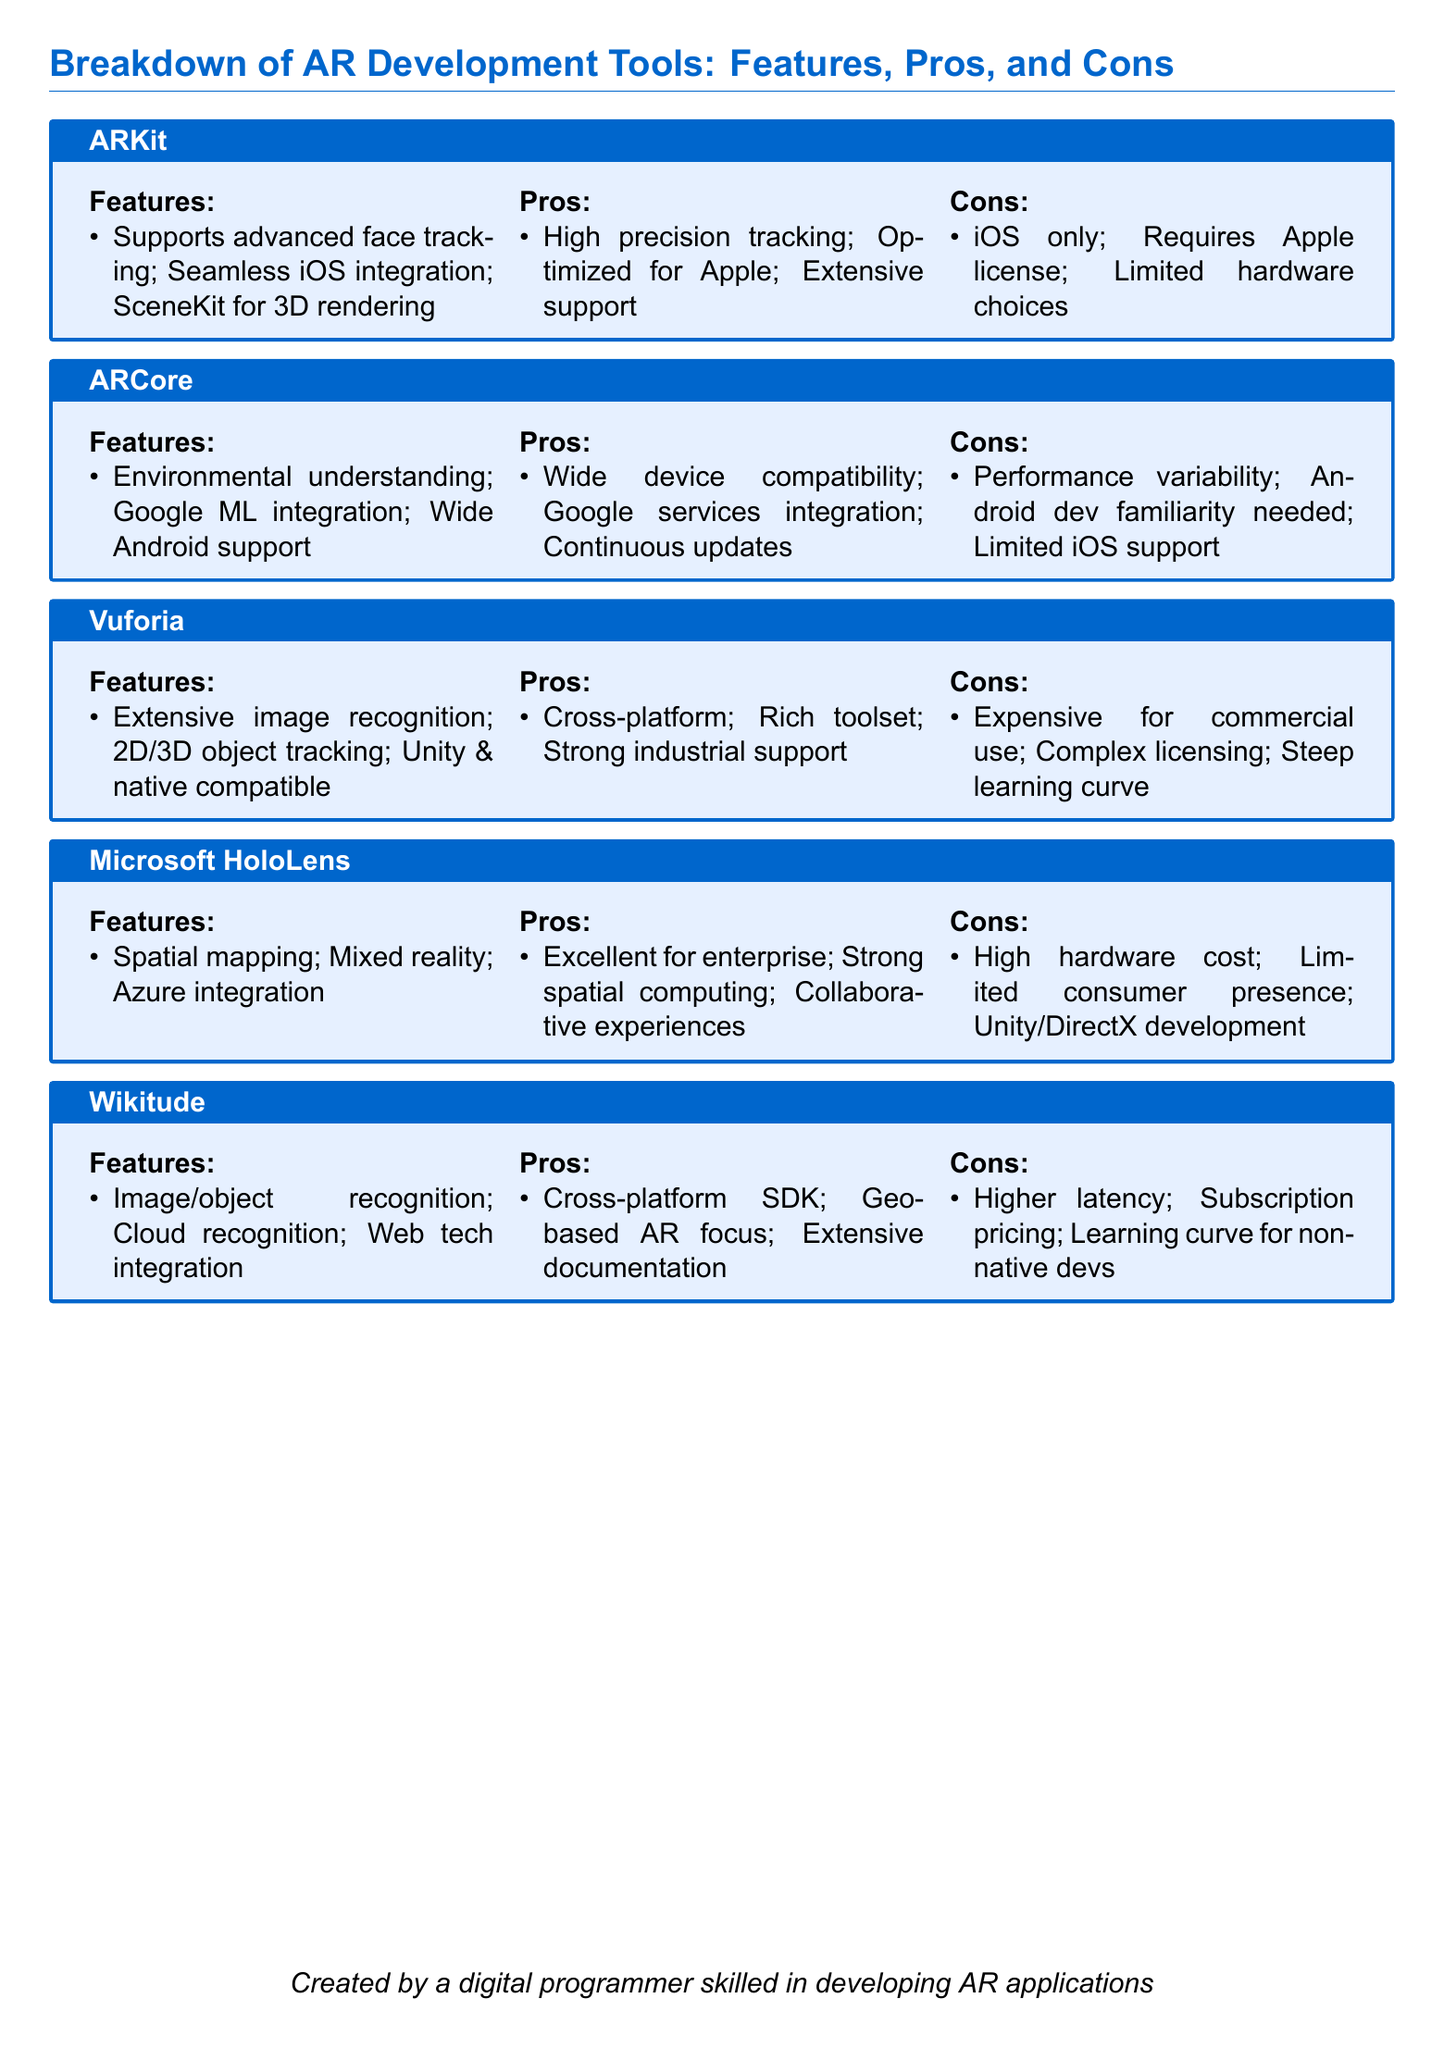What tool is iOS only? The tool that is iOS only is specified under the "Cons" section for ARKit.
Answer: ARKit What feature is unique to Vuforia? The unique feature of Vuforia mentioned is extensive image recognition.
Answer: Extensive image recognition Which tool integrates with Azure? The tool that integrates with Azure is Microsoft HoloLens.
Answer: Microsoft HoloLens What is a pro of using ARCore? A pro of using ARCore is its wide device compatibility.
Answer: Wide device compatibility What is the high hardware cost associated with? The high hardware cost is associated with Microsoft HoloLens.
Answer: Microsoft HoloLens What type of support does Vuforia provide? Vuforia provides strong industrial support.
Answer: Strong industrial support Which tool has limited iOS support? The tool that has limited iOS support is ARCore.
Answer: ARCore What is the common licensing issue with Vuforia? The common licensing issue with Vuforia is complex licensing.
Answer: Complex licensing What focus does Wikitude emphasize? Wikitude emphasizes a geo-based AR focus.
Answer: Geo-based AR focus 